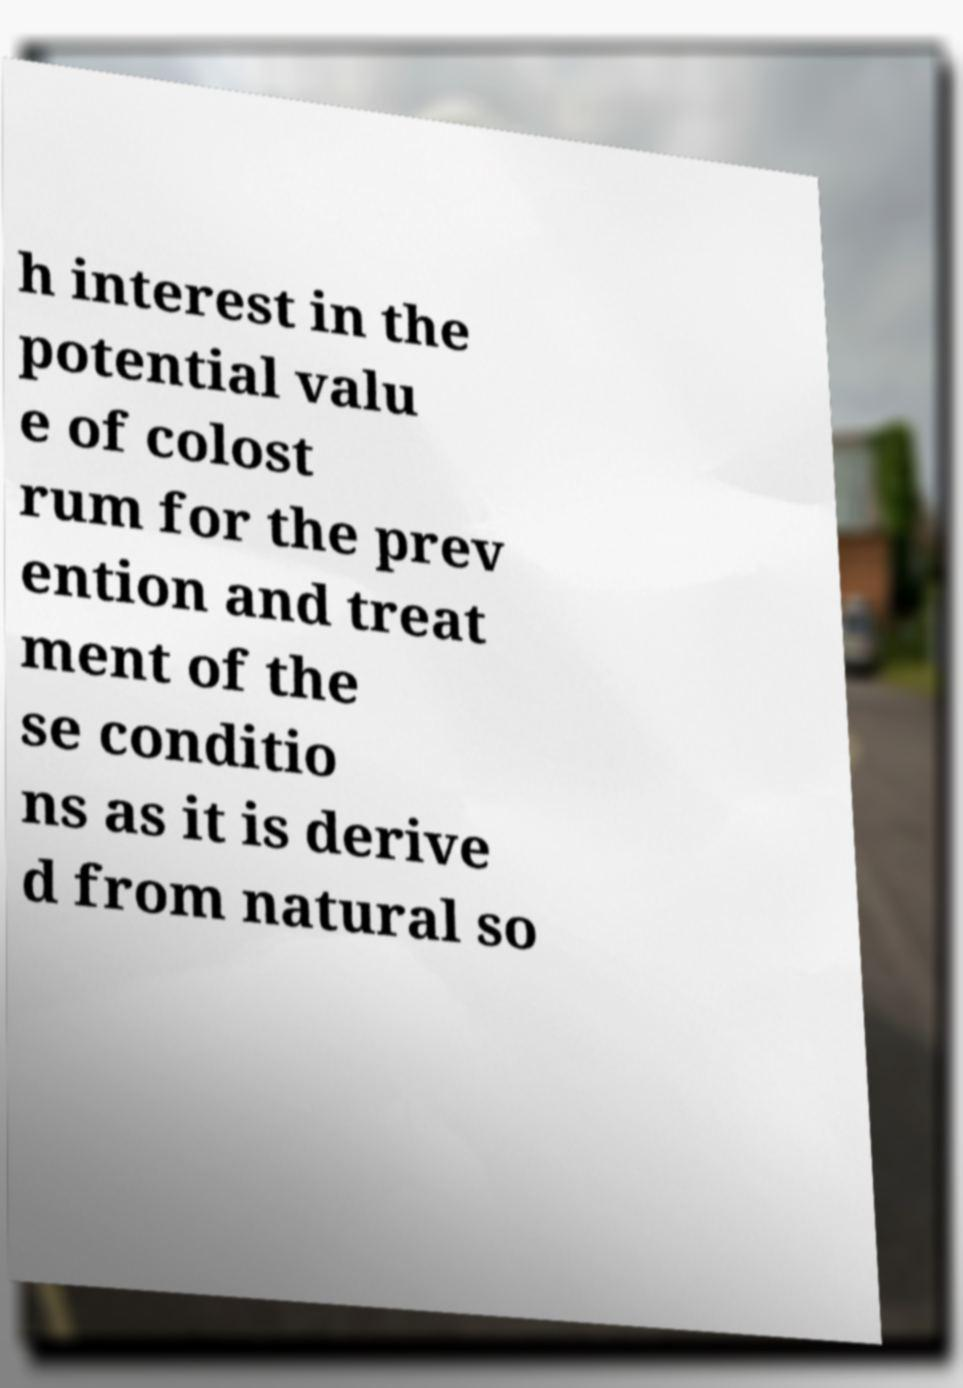Could you assist in decoding the text presented in this image and type it out clearly? h interest in the potential valu e of colost rum for the prev ention and treat ment of the se conditio ns as it is derive d from natural so 